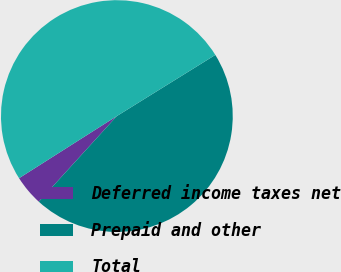Convert chart. <chart><loc_0><loc_0><loc_500><loc_500><pie_chart><fcel>Deferred income taxes net<fcel>Prepaid and other<fcel>Total<nl><fcel>4.23%<fcel>45.6%<fcel>50.16%<nl></chart> 